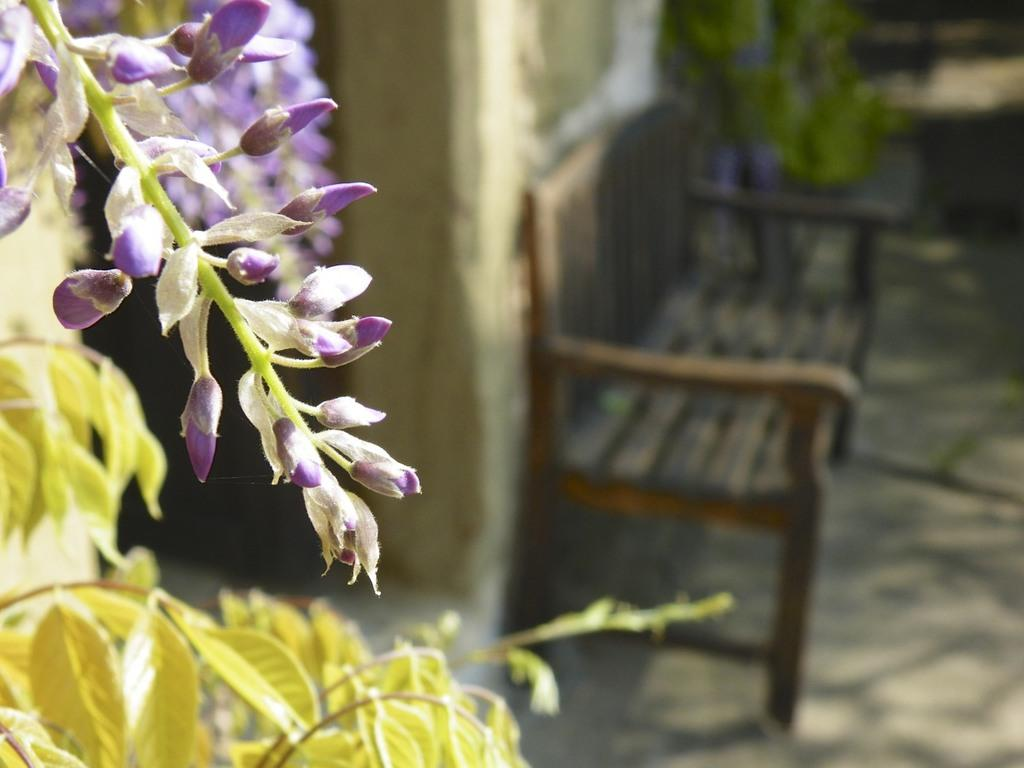What type of flowers are on the plant in the image? There are white and purple flowers on a plant in the image. What type of seating is visible in the image? There is a brown bench against a wall in the image. How would you describe the background of the image? The background of the image is blurred. What type of liquid is being served in a cup on the bench in the image? There is no cup or liquid present on the bench in the image. 